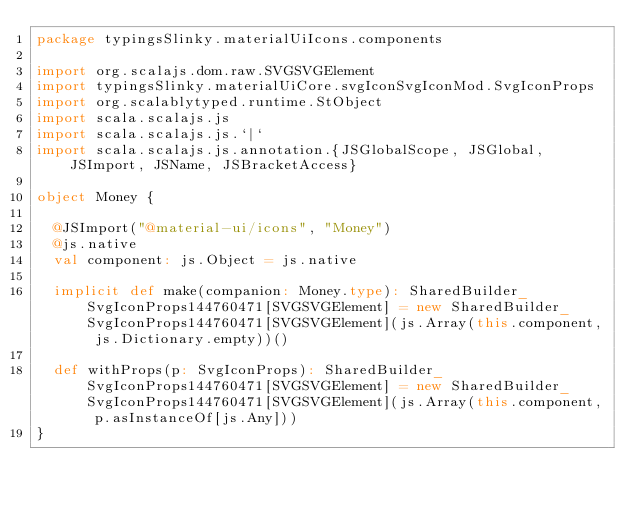Convert code to text. <code><loc_0><loc_0><loc_500><loc_500><_Scala_>package typingsSlinky.materialUiIcons.components

import org.scalajs.dom.raw.SVGSVGElement
import typingsSlinky.materialUiCore.svgIconSvgIconMod.SvgIconProps
import org.scalablytyped.runtime.StObject
import scala.scalajs.js
import scala.scalajs.js.`|`
import scala.scalajs.js.annotation.{JSGlobalScope, JSGlobal, JSImport, JSName, JSBracketAccess}

object Money {
  
  @JSImport("@material-ui/icons", "Money")
  @js.native
  val component: js.Object = js.native
  
  implicit def make(companion: Money.type): SharedBuilder_SvgIconProps144760471[SVGSVGElement] = new SharedBuilder_SvgIconProps144760471[SVGSVGElement](js.Array(this.component, js.Dictionary.empty))()
  
  def withProps(p: SvgIconProps): SharedBuilder_SvgIconProps144760471[SVGSVGElement] = new SharedBuilder_SvgIconProps144760471[SVGSVGElement](js.Array(this.component, p.asInstanceOf[js.Any]))
}
</code> 